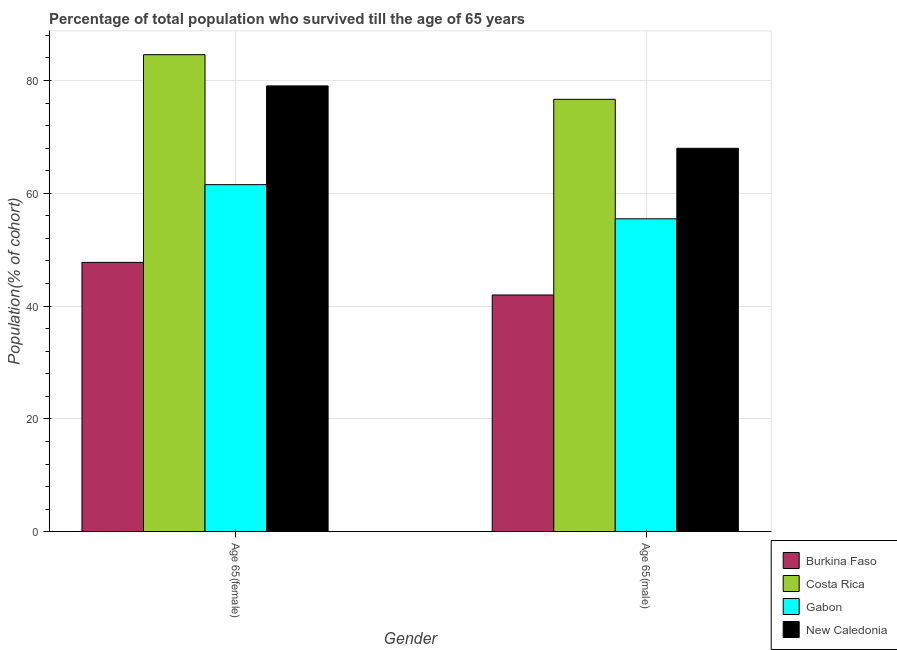How many different coloured bars are there?
Keep it short and to the point. 4. What is the label of the 1st group of bars from the left?
Make the answer very short. Age 65(female). What is the percentage of female population who survived till age of 65 in Gabon?
Offer a very short reply. 61.53. Across all countries, what is the maximum percentage of male population who survived till age of 65?
Offer a very short reply. 76.66. Across all countries, what is the minimum percentage of male population who survived till age of 65?
Your answer should be very brief. 41.97. In which country was the percentage of female population who survived till age of 65 minimum?
Keep it short and to the point. Burkina Faso. What is the total percentage of female population who survived till age of 65 in the graph?
Offer a very short reply. 272.88. What is the difference between the percentage of male population who survived till age of 65 in New Caledonia and that in Burkina Faso?
Offer a very short reply. 26. What is the difference between the percentage of male population who survived till age of 65 in Gabon and the percentage of female population who survived till age of 65 in Burkina Faso?
Make the answer very short. 7.73. What is the average percentage of female population who survived till age of 65 per country?
Your answer should be compact. 68.22. What is the difference between the percentage of female population who survived till age of 65 and percentage of male population who survived till age of 65 in Gabon?
Provide a short and direct response. 6.05. What is the ratio of the percentage of male population who survived till age of 65 in Gabon to that in Burkina Faso?
Keep it short and to the point. 1.32. What does the 4th bar from the left in Age 65(female) represents?
Give a very brief answer. New Caledonia. What does the 2nd bar from the right in Age 65(female) represents?
Offer a very short reply. Gabon. How many bars are there?
Ensure brevity in your answer.  8. How many countries are there in the graph?
Your response must be concise. 4. Does the graph contain any zero values?
Offer a very short reply. No. What is the title of the graph?
Offer a terse response. Percentage of total population who survived till the age of 65 years. What is the label or title of the Y-axis?
Provide a short and direct response. Population(% of cohort). What is the Population(% of cohort) of Burkina Faso in Age 65(female)?
Your response must be concise. 47.75. What is the Population(% of cohort) in Costa Rica in Age 65(female)?
Keep it short and to the point. 84.57. What is the Population(% of cohort) of Gabon in Age 65(female)?
Your answer should be compact. 61.53. What is the Population(% of cohort) of New Caledonia in Age 65(female)?
Keep it short and to the point. 79.03. What is the Population(% of cohort) in Burkina Faso in Age 65(male)?
Give a very brief answer. 41.97. What is the Population(% of cohort) in Costa Rica in Age 65(male)?
Provide a short and direct response. 76.66. What is the Population(% of cohort) of Gabon in Age 65(male)?
Offer a terse response. 55.47. What is the Population(% of cohort) of New Caledonia in Age 65(male)?
Your answer should be very brief. 67.97. Across all Gender, what is the maximum Population(% of cohort) of Burkina Faso?
Provide a succinct answer. 47.75. Across all Gender, what is the maximum Population(% of cohort) of Costa Rica?
Offer a very short reply. 84.57. Across all Gender, what is the maximum Population(% of cohort) in Gabon?
Your answer should be very brief. 61.53. Across all Gender, what is the maximum Population(% of cohort) of New Caledonia?
Keep it short and to the point. 79.03. Across all Gender, what is the minimum Population(% of cohort) of Burkina Faso?
Make the answer very short. 41.97. Across all Gender, what is the minimum Population(% of cohort) of Costa Rica?
Provide a short and direct response. 76.66. Across all Gender, what is the minimum Population(% of cohort) in Gabon?
Offer a terse response. 55.47. Across all Gender, what is the minimum Population(% of cohort) in New Caledonia?
Keep it short and to the point. 67.97. What is the total Population(% of cohort) in Burkina Faso in the graph?
Give a very brief answer. 89.71. What is the total Population(% of cohort) of Costa Rica in the graph?
Your response must be concise. 161.23. What is the total Population(% of cohort) in Gabon in the graph?
Keep it short and to the point. 117. What is the total Population(% of cohort) in New Caledonia in the graph?
Make the answer very short. 147.01. What is the difference between the Population(% of cohort) of Burkina Faso in Age 65(female) and that in Age 65(male)?
Keep it short and to the point. 5.78. What is the difference between the Population(% of cohort) in Costa Rica in Age 65(female) and that in Age 65(male)?
Your answer should be compact. 7.92. What is the difference between the Population(% of cohort) of Gabon in Age 65(female) and that in Age 65(male)?
Ensure brevity in your answer.  6.05. What is the difference between the Population(% of cohort) of New Caledonia in Age 65(female) and that in Age 65(male)?
Keep it short and to the point. 11.06. What is the difference between the Population(% of cohort) of Burkina Faso in Age 65(female) and the Population(% of cohort) of Costa Rica in Age 65(male)?
Provide a succinct answer. -28.91. What is the difference between the Population(% of cohort) of Burkina Faso in Age 65(female) and the Population(% of cohort) of Gabon in Age 65(male)?
Offer a terse response. -7.73. What is the difference between the Population(% of cohort) in Burkina Faso in Age 65(female) and the Population(% of cohort) in New Caledonia in Age 65(male)?
Offer a very short reply. -20.23. What is the difference between the Population(% of cohort) of Costa Rica in Age 65(female) and the Population(% of cohort) of Gabon in Age 65(male)?
Your answer should be compact. 29.1. What is the difference between the Population(% of cohort) in Costa Rica in Age 65(female) and the Population(% of cohort) in New Caledonia in Age 65(male)?
Offer a terse response. 16.6. What is the difference between the Population(% of cohort) of Gabon in Age 65(female) and the Population(% of cohort) of New Caledonia in Age 65(male)?
Provide a succinct answer. -6.45. What is the average Population(% of cohort) of Burkina Faso per Gender?
Make the answer very short. 44.86. What is the average Population(% of cohort) of Costa Rica per Gender?
Offer a very short reply. 80.61. What is the average Population(% of cohort) of Gabon per Gender?
Provide a short and direct response. 58.5. What is the average Population(% of cohort) in New Caledonia per Gender?
Give a very brief answer. 73.5. What is the difference between the Population(% of cohort) of Burkina Faso and Population(% of cohort) of Costa Rica in Age 65(female)?
Provide a short and direct response. -36.82. What is the difference between the Population(% of cohort) in Burkina Faso and Population(% of cohort) in Gabon in Age 65(female)?
Your response must be concise. -13.78. What is the difference between the Population(% of cohort) in Burkina Faso and Population(% of cohort) in New Caledonia in Age 65(female)?
Offer a terse response. -31.29. What is the difference between the Population(% of cohort) of Costa Rica and Population(% of cohort) of Gabon in Age 65(female)?
Your response must be concise. 23.04. What is the difference between the Population(% of cohort) in Costa Rica and Population(% of cohort) in New Caledonia in Age 65(female)?
Give a very brief answer. 5.54. What is the difference between the Population(% of cohort) in Gabon and Population(% of cohort) in New Caledonia in Age 65(female)?
Your answer should be compact. -17.51. What is the difference between the Population(% of cohort) in Burkina Faso and Population(% of cohort) in Costa Rica in Age 65(male)?
Give a very brief answer. -34.69. What is the difference between the Population(% of cohort) in Burkina Faso and Population(% of cohort) in Gabon in Age 65(male)?
Make the answer very short. -13.5. What is the difference between the Population(% of cohort) of Burkina Faso and Population(% of cohort) of New Caledonia in Age 65(male)?
Make the answer very short. -26. What is the difference between the Population(% of cohort) in Costa Rica and Population(% of cohort) in Gabon in Age 65(male)?
Keep it short and to the point. 21.18. What is the difference between the Population(% of cohort) in Costa Rica and Population(% of cohort) in New Caledonia in Age 65(male)?
Your answer should be compact. 8.68. What is the ratio of the Population(% of cohort) in Burkina Faso in Age 65(female) to that in Age 65(male)?
Make the answer very short. 1.14. What is the ratio of the Population(% of cohort) in Costa Rica in Age 65(female) to that in Age 65(male)?
Offer a terse response. 1.1. What is the ratio of the Population(% of cohort) of Gabon in Age 65(female) to that in Age 65(male)?
Provide a succinct answer. 1.11. What is the ratio of the Population(% of cohort) in New Caledonia in Age 65(female) to that in Age 65(male)?
Offer a terse response. 1.16. What is the difference between the highest and the second highest Population(% of cohort) in Burkina Faso?
Offer a very short reply. 5.78. What is the difference between the highest and the second highest Population(% of cohort) of Costa Rica?
Provide a succinct answer. 7.92. What is the difference between the highest and the second highest Population(% of cohort) in Gabon?
Provide a short and direct response. 6.05. What is the difference between the highest and the second highest Population(% of cohort) in New Caledonia?
Ensure brevity in your answer.  11.06. What is the difference between the highest and the lowest Population(% of cohort) in Burkina Faso?
Offer a very short reply. 5.78. What is the difference between the highest and the lowest Population(% of cohort) of Costa Rica?
Your answer should be very brief. 7.92. What is the difference between the highest and the lowest Population(% of cohort) of Gabon?
Your response must be concise. 6.05. What is the difference between the highest and the lowest Population(% of cohort) in New Caledonia?
Ensure brevity in your answer.  11.06. 